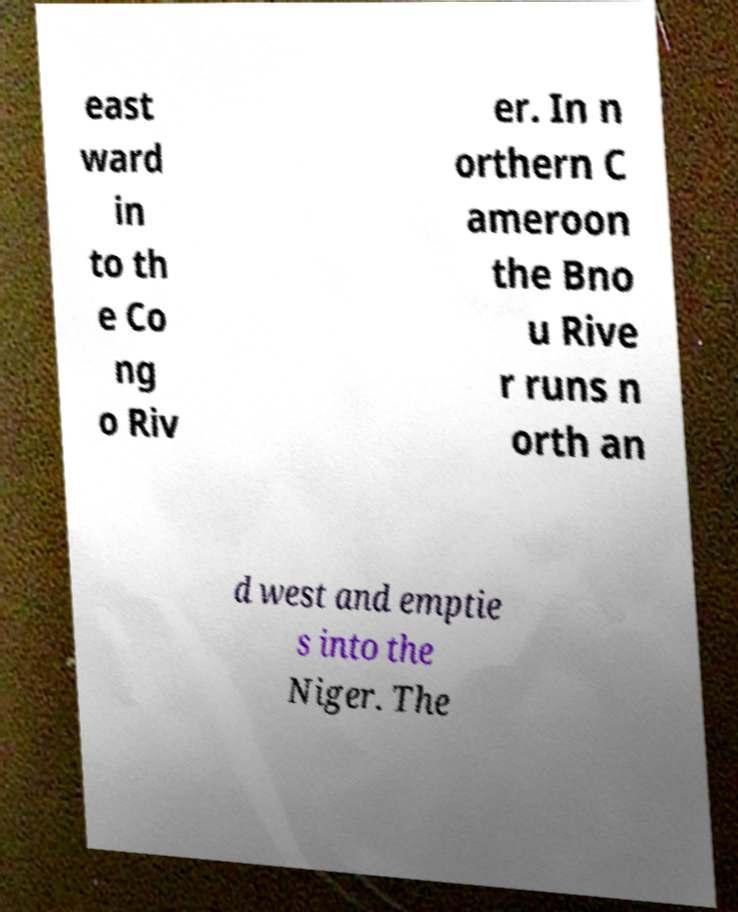Please read and relay the text visible in this image. What does it say? east ward in to th e Co ng o Riv er. In n orthern C ameroon the Bno u Rive r runs n orth an d west and emptie s into the Niger. The 